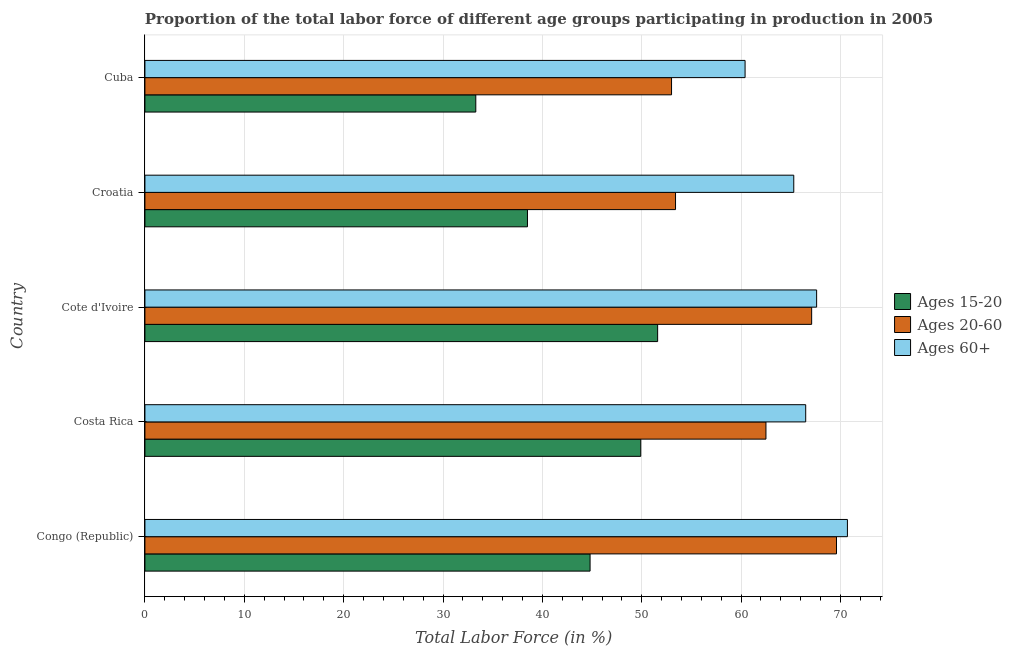How many different coloured bars are there?
Provide a succinct answer. 3. Are the number of bars per tick equal to the number of legend labels?
Keep it short and to the point. Yes. What is the label of the 5th group of bars from the top?
Your answer should be compact. Congo (Republic). What is the percentage of labor force above age 60 in Croatia?
Keep it short and to the point. 65.3. Across all countries, what is the maximum percentage of labor force above age 60?
Offer a very short reply. 70.7. Across all countries, what is the minimum percentage of labor force within the age group 15-20?
Your response must be concise. 33.3. In which country was the percentage of labor force within the age group 20-60 maximum?
Ensure brevity in your answer.  Congo (Republic). In which country was the percentage of labor force within the age group 20-60 minimum?
Give a very brief answer. Cuba. What is the total percentage of labor force above age 60 in the graph?
Provide a short and direct response. 330.5. What is the difference between the percentage of labor force within the age group 15-20 in Croatia and the percentage of labor force within the age group 20-60 in Cote d'Ivoire?
Provide a succinct answer. -28.6. What is the average percentage of labor force within the age group 15-20 per country?
Offer a terse response. 43.62. What is the difference between the percentage of labor force within the age group 20-60 and percentage of labor force within the age group 15-20 in Croatia?
Provide a succinct answer. 14.9. What is the ratio of the percentage of labor force within the age group 20-60 in Congo (Republic) to that in Cuba?
Provide a short and direct response. 1.31. Is the percentage of labor force within the age group 20-60 in Costa Rica less than that in Cuba?
Make the answer very short. No. Is the difference between the percentage of labor force above age 60 in Croatia and Cuba greater than the difference between the percentage of labor force within the age group 20-60 in Croatia and Cuba?
Offer a terse response. Yes. What is the difference between the highest and the lowest percentage of labor force within the age group 20-60?
Offer a very short reply. 16.6. In how many countries, is the percentage of labor force within the age group 20-60 greater than the average percentage of labor force within the age group 20-60 taken over all countries?
Keep it short and to the point. 3. What does the 1st bar from the top in Costa Rica represents?
Give a very brief answer. Ages 60+. What does the 1st bar from the bottom in Croatia represents?
Provide a succinct answer. Ages 15-20. Are the values on the major ticks of X-axis written in scientific E-notation?
Provide a short and direct response. No. Does the graph contain any zero values?
Provide a short and direct response. No. Does the graph contain grids?
Your answer should be very brief. Yes. How many legend labels are there?
Offer a terse response. 3. What is the title of the graph?
Your response must be concise. Proportion of the total labor force of different age groups participating in production in 2005. Does "Transport equipments" appear as one of the legend labels in the graph?
Offer a terse response. No. What is the Total Labor Force (in %) of Ages 15-20 in Congo (Republic)?
Your answer should be very brief. 44.8. What is the Total Labor Force (in %) in Ages 20-60 in Congo (Republic)?
Give a very brief answer. 69.6. What is the Total Labor Force (in %) in Ages 60+ in Congo (Republic)?
Your answer should be compact. 70.7. What is the Total Labor Force (in %) of Ages 15-20 in Costa Rica?
Your response must be concise. 49.9. What is the Total Labor Force (in %) of Ages 20-60 in Costa Rica?
Your response must be concise. 62.5. What is the Total Labor Force (in %) of Ages 60+ in Costa Rica?
Your answer should be very brief. 66.5. What is the Total Labor Force (in %) of Ages 15-20 in Cote d'Ivoire?
Your response must be concise. 51.6. What is the Total Labor Force (in %) in Ages 20-60 in Cote d'Ivoire?
Your response must be concise. 67.1. What is the Total Labor Force (in %) of Ages 60+ in Cote d'Ivoire?
Provide a short and direct response. 67.6. What is the Total Labor Force (in %) in Ages 15-20 in Croatia?
Make the answer very short. 38.5. What is the Total Labor Force (in %) of Ages 20-60 in Croatia?
Your response must be concise. 53.4. What is the Total Labor Force (in %) in Ages 60+ in Croatia?
Provide a succinct answer. 65.3. What is the Total Labor Force (in %) in Ages 15-20 in Cuba?
Your response must be concise. 33.3. What is the Total Labor Force (in %) of Ages 60+ in Cuba?
Your answer should be very brief. 60.4. Across all countries, what is the maximum Total Labor Force (in %) of Ages 15-20?
Your answer should be very brief. 51.6. Across all countries, what is the maximum Total Labor Force (in %) in Ages 20-60?
Ensure brevity in your answer.  69.6. Across all countries, what is the maximum Total Labor Force (in %) of Ages 60+?
Offer a very short reply. 70.7. Across all countries, what is the minimum Total Labor Force (in %) in Ages 15-20?
Offer a terse response. 33.3. Across all countries, what is the minimum Total Labor Force (in %) of Ages 60+?
Provide a short and direct response. 60.4. What is the total Total Labor Force (in %) in Ages 15-20 in the graph?
Provide a short and direct response. 218.1. What is the total Total Labor Force (in %) in Ages 20-60 in the graph?
Offer a very short reply. 305.6. What is the total Total Labor Force (in %) of Ages 60+ in the graph?
Offer a terse response. 330.5. What is the difference between the Total Labor Force (in %) in Ages 15-20 in Congo (Republic) and that in Costa Rica?
Give a very brief answer. -5.1. What is the difference between the Total Labor Force (in %) of Ages 20-60 in Congo (Republic) and that in Costa Rica?
Make the answer very short. 7.1. What is the difference between the Total Labor Force (in %) of Ages 60+ in Congo (Republic) and that in Cuba?
Give a very brief answer. 10.3. What is the difference between the Total Labor Force (in %) in Ages 15-20 in Costa Rica and that in Cote d'Ivoire?
Provide a short and direct response. -1.7. What is the difference between the Total Labor Force (in %) of Ages 15-20 in Costa Rica and that in Croatia?
Offer a very short reply. 11.4. What is the difference between the Total Labor Force (in %) of Ages 20-60 in Costa Rica and that in Croatia?
Provide a short and direct response. 9.1. What is the difference between the Total Labor Force (in %) in Ages 60+ in Costa Rica and that in Croatia?
Provide a short and direct response. 1.2. What is the difference between the Total Labor Force (in %) of Ages 20-60 in Costa Rica and that in Cuba?
Provide a short and direct response. 9.5. What is the difference between the Total Labor Force (in %) in Ages 20-60 in Cote d'Ivoire and that in Croatia?
Make the answer very short. 13.7. What is the difference between the Total Labor Force (in %) of Ages 60+ in Cote d'Ivoire and that in Cuba?
Your answer should be compact. 7.2. What is the difference between the Total Labor Force (in %) in Ages 15-20 in Croatia and that in Cuba?
Offer a terse response. 5.2. What is the difference between the Total Labor Force (in %) in Ages 20-60 in Croatia and that in Cuba?
Make the answer very short. 0.4. What is the difference between the Total Labor Force (in %) in Ages 15-20 in Congo (Republic) and the Total Labor Force (in %) in Ages 20-60 in Costa Rica?
Your answer should be compact. -17.7. What is the difference between the Total Labor Force (in %) in Ages 15-20 in Congo (Republic) and the Total Labor Force (in %) in Ages 60+ in Costa Rica?
Your answer should be compact. -21.7. What is the difference between the Total Labor Force (in %) in Ages 15-20 in Congo (Republic) and the Total Labor Force (in %) in Ages 20-60 in Cote d'Ivoire?
Keep it short and to the point. -22.3. What is the difference between the Total Labor Force (in %) of Ages 15-20 in Congo (Republic) and the Total Labor Force (in %) of Ages 60+ in Cote d'Ivoire?
Give a very brief answer. -22.8. What is the difference between the Total Labor Force (in %) of Ages 15-20 in Congo (Republic) and the Total Labor Force (in %) of Ages 20-60 in Croatia?
Provide a short and direct response. -8.6. What is the difference between the Total Labor Force (in %) in Ages 15-20 in Congo (Republic) and the Total Labor Force (in %) in Ages 60+ in Croatia?
Provide a short and direct response. -20.5. What is the difference between the Total Labor Force (in %) of Ages 20-60 in Congo (Republic) and the Total Labor Force (in %) of Ages 60+ in Croatia?
Offer a terse response. 4.3. What is the difference between the Total Labor Force (in %) in Ages 15-20 in Congo (Republic) and the Total Labor Force (in %) in Ages 20-60 in Cuba?
Your answer should be very brief. -8.2. What is the difference between the Total Labor Force (in %) of Ages 15-20 in Congo (Republic) and the Total Labor Force (in %) of Ages 60+ in Cuba?
Your answer should be compact. -15.6. What is the difference between the Total Labor Force (in %) in Ages 15-20 in Costa Rica and the Total Labor Force (in %) in Ages 20-60 in Cote d'Ivoire?
Make the answer very short. -17.2. What is the difference between the Total Labor Force (in %) in Ages 15-20 in Costa Rica and the Total Labor Force (in %) in Ages 60+ in Cote d'Ivoire?
Keep it short and to the point. -17.7. What is the difference between the Total Labor Force (in %) in Ages 20-60 in Costa Rica and the Total Labor Force (in %) in Ages 60+ in Cote d'Ivoire?
Ensure brevity in your answer.  -5.1. What is the difference between the Total Labor Force (in %) in Ages 15-20 in Costa Rica and the Total Labor Force (in %) in Ages 60+ in Croatia?
Offer a terse response. -15.4. What is the difference between the Total Labor Force (in %) of Ages 15-20 in Costa Rica and the Total Labor Force (in %) of Ages 20-60 in Cuba?
Give a very brief answer. -3.1. What is the difference between the Total Labor Force (in %) in Ages 15-20 in Costa Rica and the Total Labor Force (in %) in Ages 60+ in Cuba?
Ensure brevity in your answer.  -10.5. What is the difference between the Total Labor Force (in %) in Ages 15-20 in Cote d'Ivoire and the Total Labor Force (in %) in Ages 20-60 in Croatia?
Your answer should be very brief. -1.8. What is the difference between the Total Labor Force (in %) of Ages 15-20 in Cote d'Ivoire and the Total Labor Force (in %) of Ages 60+ in Croatia?
Your answer should be compact. -13.7. What is the difference between the Total Labor Force (in %) in Ages 20-60 in Cote d'Ivoire and the Total Labor Force (in %) in Ages 60+ in Croatia?
Give a very brief answer. 1.8. What is the difference between the Total Labor Force (in %) of Ages 15-20 in Cote d'Ivoire and the Total Labor Force (in %) of Ages 60+ in Cuba?
Offer a terse response. -8.8. What is the difference between the Total Labor Force (in %) of Ages 15-20 in Croatia and the Total Labor Force (in %) of Ages 60+ in Cuba?
Your answer should be very brief. -21.9. What is the difference between the Total Labor Force (in %) in Ages 20-60 in Croatia and the Total Labor Force (in %) in Ages 60+ in Cuba?
Provide a short and direct response. -7. What is the average Total Labor Force (in %) of Ages 15-20 per country?
Your answer should be compact. 43.62. What is the average Total Labor Force (in %) in Ages 20-60 per country?
Your answer should be very brief. 61.12. What is the average Total Labor Force (in %) of Ages 60+ per country?
Offer a very short reply. 66.1. What is the difference between the Total Labor Force (in %) of Ages 15-20 and Total Labor Force (in %) of Ages 20-60 in Congo (Republic)?
Provide a succinct answer. -24.8. What is the difference between the Total Labor Force (in %) in Ages 15-20 and Total Labor Force (in %) in Ages 60+ in Congo (Republic)?
Offer a terse response. -25.9. What is the difference between the Total Labor Force (in %) in Ages 20-60 and Total Labor Force (in %) in Ages 60+ in Congo (Republic)?
Make the answer very short. -1.1. What is the difference between the Total Labor Force (in %) in Ages 15-20 and Total Labor Force (in %) in Ages 20-60 in Costa Rica?
Offer a very short reply. -12.6. What is the difference between the Total Labor Force (in %) in Ages 15-20 and Total Labor Force (in %) in Ages 60+ in Costa Rica?
Give a very brief answer. -16.6. What is the difference between the Total Labor Force (in %) of Ages 15-20 and Total Labor Force (in %) of Ages 20-60 in Cote d'Ivoire?
Keep it short and to the point. -15.5. What is the difference between the Total Labor Force (in %) in Ages 15-20 and Total Labor Force (in %) in Ages 60+ in Cote d'Ivoire?
Ensure brevity in your answer.  -16. What is the difference between the Total Labor Force (in %) in Ages 20-60 and Total Labor Force (in %) in Ages 60+ in Cote d'Ivoire?
Provide a short and direct response. -0.5. What is the difference between the Total Labor Force (in %) in Ages 15-20 and Total Labor Force (in %) in Ages 20-60 in Croatia?
Keep it short and to the point. -14.9. What is the difference between the Total Labor Force (in %) of Ages 15-20 and Total Labor Force (in %) of Ages 60+ in Croatia?
Keep it short and to the point. -26.8. What is the difference between the Total Labor Force (in %) of Ages 20-60 and Total Labor Force (in %) of Ages 60+ in Croatia?
Ensure brevity in your answer.  -11.9. What is the difference between the Total Labor Force (in %) of Ages 15-20 and Total Labor Force (in %) of Ages 20-60 in Cuba?
Offer a terse response. -19.7. What is the difference between the Total Labor Force (in %) in Ages 15-20 and Total Labor Force (in %) in Ages 60+ in Cuba?
Your response must be concise. -27.1. What is the difference between the Total Labor Force (in %) of Ages 20-60 and Total Labor Force (in %) of Ages 60+ in Cuba?
Provide a short and direct response. -7.4. What is the ratio of the Total Labor Force (in %) in Ages 15-20 in Congo (Republic) to that in Costa Rica?
Provide a succinct answer. 0.9. What is the ratio of the Total Labor Force (in %) of Ages 20-60 in Congo (Republic) to that in Costa Rica?
Your answer should be compact. 1.11. What is the ratio of the Total Labor Force (in %) in Ages 60+ in Congo (Republic) to that in Costa Rica?
Offer a very short reply. 1.06. What is the ratio of the Total Labor Force (in %) of Ages 15-20 in Congo (Republic) to that in Cote d'Ivoire?
Your answer should be very brief. 0.87. What is the ratio of the Total Labor Force (in %) in Ages 20-60 in Congo (Republic) to that in Cote d'Ivoire?
Your response must be concise. 1.04. What is the ratio of the Total Labor Force (in %) of Ages 60+ in Congo (Republic) to that in Cote d'Ivoire?
Provide a succinct answer. 1.05. What is the ratio of the Total Labor Force (in %) in Ages 15-20 in Congo (Republic) to that in Croatia?
Make the answer very short. 1.16. What is the ratio of the Total Labor Force (in %) in Ages 20-60 in Congo (Republic) to that in Croatia?
Provide a succinct answer. 1.3. What is the ratio of the Total Labor Force (in %) of Ages 60+ in Congo (Republic) to that in Croatia?
Ensure brevity in your answer.  1.08. What is the ratio of the Total Labor Force (in %) in Ages 15-20 in Congo (Republic) to that in Cuba?
Keep it short and to the point. 1.35. What is the ratio of the Total Labor Force (in %) in Ages 20-60 in Congo (Republic) to that in Cuba?
Give a very brief answer. 1.31. What is the ratio of the Total Labor Force (in %) of Ages 60+ in Congo (Republic) to that in Cuba?
Your response must be concise. 1.17. What is the ratio of the Total Labor Force (in %) of Ages 15-20 in Costa Rica to that in Cote d'Ivoire?
Offer a very short reply. 0.97. What is the ratio of the Total Labor Force (in %) in Ages 20-60 in Costa Rica to that in Cote d'Ivoire?
Your response must be concise. 0.93. What is the ratio of the Total Labor Force (in %) in Ages 60+ in Costa Rica to that in Cote d'Ivoire?
Offer a very short reply. 0.98. What is the ratio of the Total Labor Force (in %) of Ages 15-20 in Costa Rica to that in Croatia?
Keep it short and to the point. 1.3. What is the ratio of the Total Labor Force (in %) of Ages 20-60 in Costa Rica to that in Croatia?
Your answer should be compact. 1.17. What is the ratio of the Total Labor Force (in %) of Ages 60+ in Costa Rica to that in Croatia?
Ensure brevity in your answer.  1.02. What is the ratio of the Total Labor Force (in %) in Ages 15-20 in Costa Rica to that in Cuba?
Offer a terse response. 1.5. What is the ratio of the Total Labor Force (in %) of Ages 20-60 in Costa Rica to that in Cuba?
Your response must be concise. 1.18. What is the ratio of the Total Labor Force (in %) in Ages 60+ in Costa Rica to that in Cuba?
Make the answer very short. 1.1. What is the ratio of the Total Labor Force (in %) in Ages 15-20 in Cote d'Ivoire to that in Croatia?
Your response must be concise. 1.34. What is the ratio of the Total Labor Force (in %) of Ages 20-60 in Cote d'Ivoire to that in Croatia?
Your response must be concise. 1.26. What is the ratio of the Total Labor Force (in %) of Ages 60+ in Cote d'Ivoire to that in Croatia?
Your answer should be very brief. 1.04. What is the ratio of the Total Labor Force (in %) of Ages 15-20 in Cote d'Ivoire to that in Cuba?
Your response must be concise. 1.55. What is the ratio of the Total Labor Force (in %) in Ages 20-60 in Cote d'Ivoire to that in Cuba?
Give a very brief answer. 1.27. What is the ratio of the Total Labor Force (in %) in Ages 60+ in Cote d'Ivoire to that in Cuba?
Keep it short and to the point. 1.12. What is the ratio of the Total Labor Force (in %) of Ages 15-20 in Croatia to that in Cuba?
Your answer should be compact. 1.16. What is the ratio of the Total Labor Force (in %) of Ages 20-60 in Croatia to that in Cuba?
Keep it short and to the point. 1.01. What is the ratio of the Total Labor Force (in %) in Ages 60+ in Croatia to that in Cuba?
Give a very brief answer. 1.08. What is the difference between the highest and the second highest Total Labor Force (in %) in Ages 60+?
Ensure brevity in your answer.  3.1. What is the difference between the highest and the lowest Total Labor Force (in %) in Ages 20-60?
Your response must be concise. 16.6. 